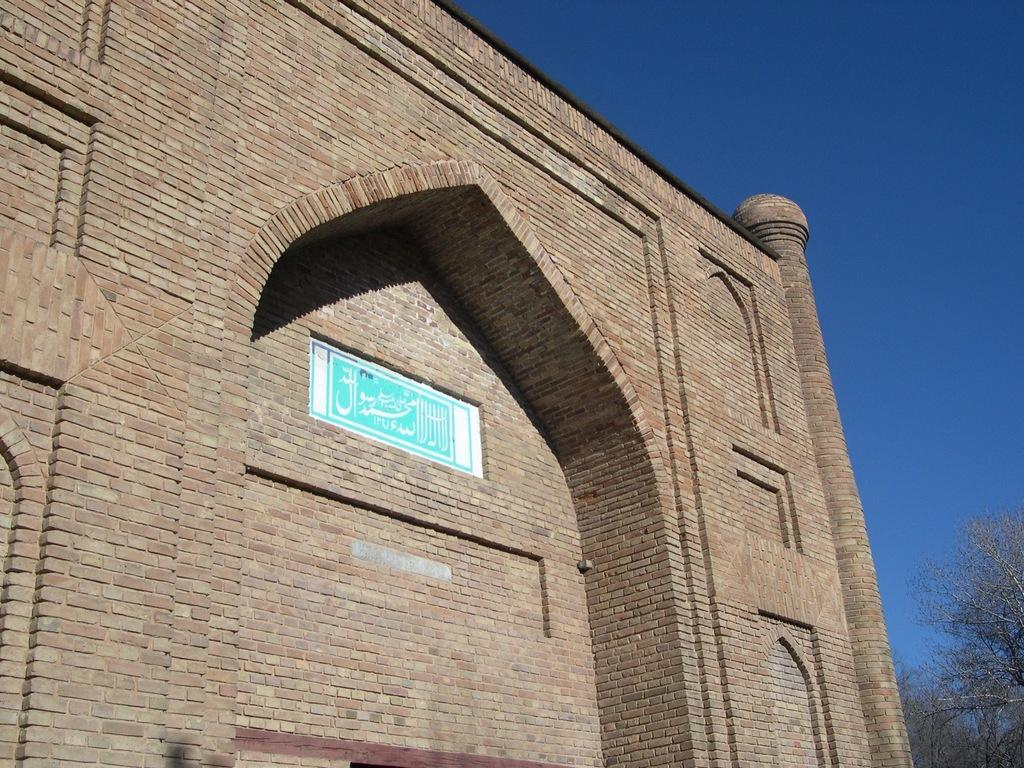What type of building is featured in the image? There is a building with a brick wall in the image. What can be seen on the building besides the brick wall? There is a board with white and blue colors on the building. What is written on the board? Something is written on the board, but the specific message cannot be determined from the image. What is visible in the background of the image? The sky and trees are visible in the background of the image. Where is the scarecrow located in the image? There is no scarecrow present in the image. What discovery was made while observing the board on the building? There is no indication of a discovery being made in the image; it simply shows a board with writing on it. 